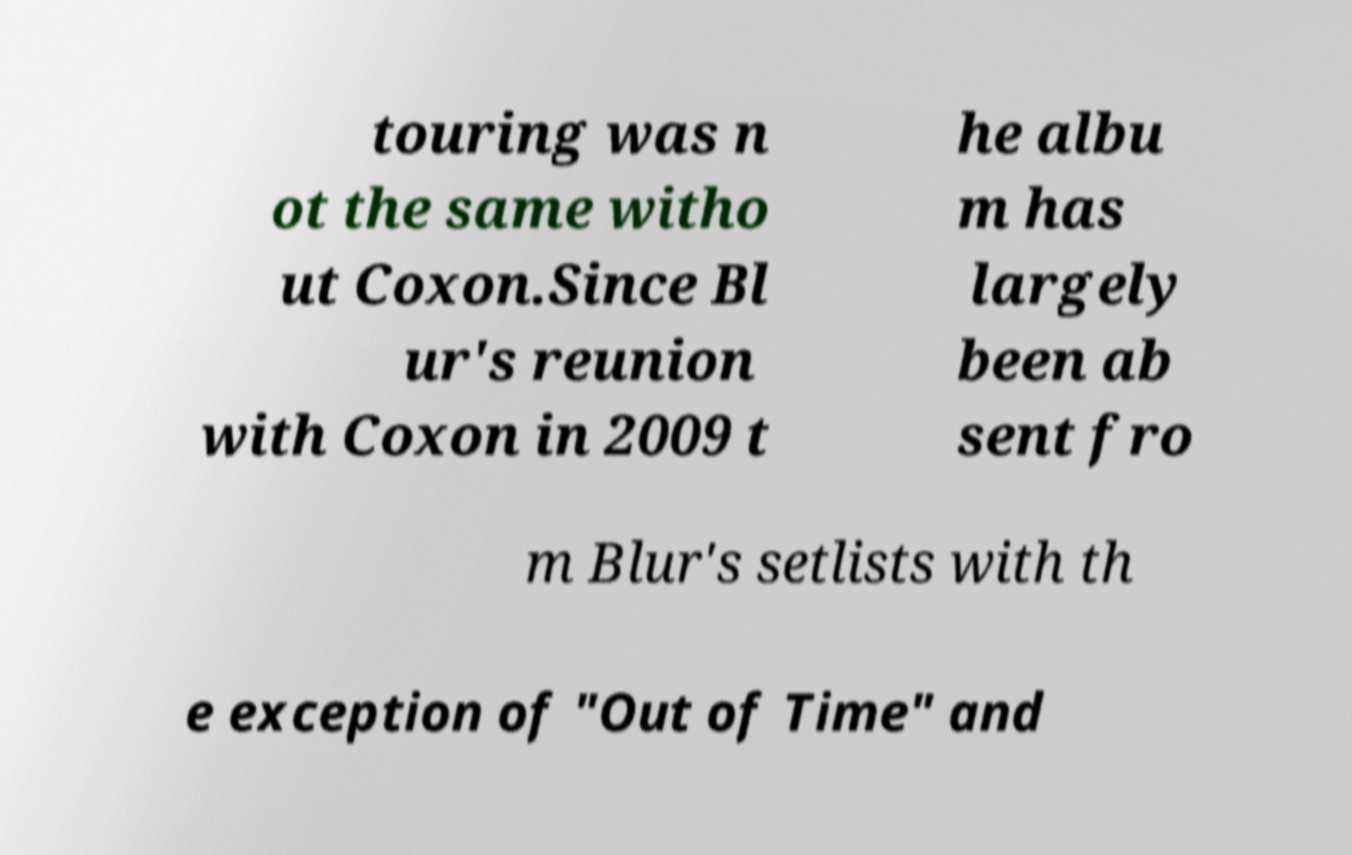Please identify and transcribe the text found in this image. touring was n ot the same witho ut Coxon.Since Bl ur's reunion with Coxon in 2009 t he albu m has largely been ab sent fro m Blur's setlists with th e exception of "Out of Time" and 